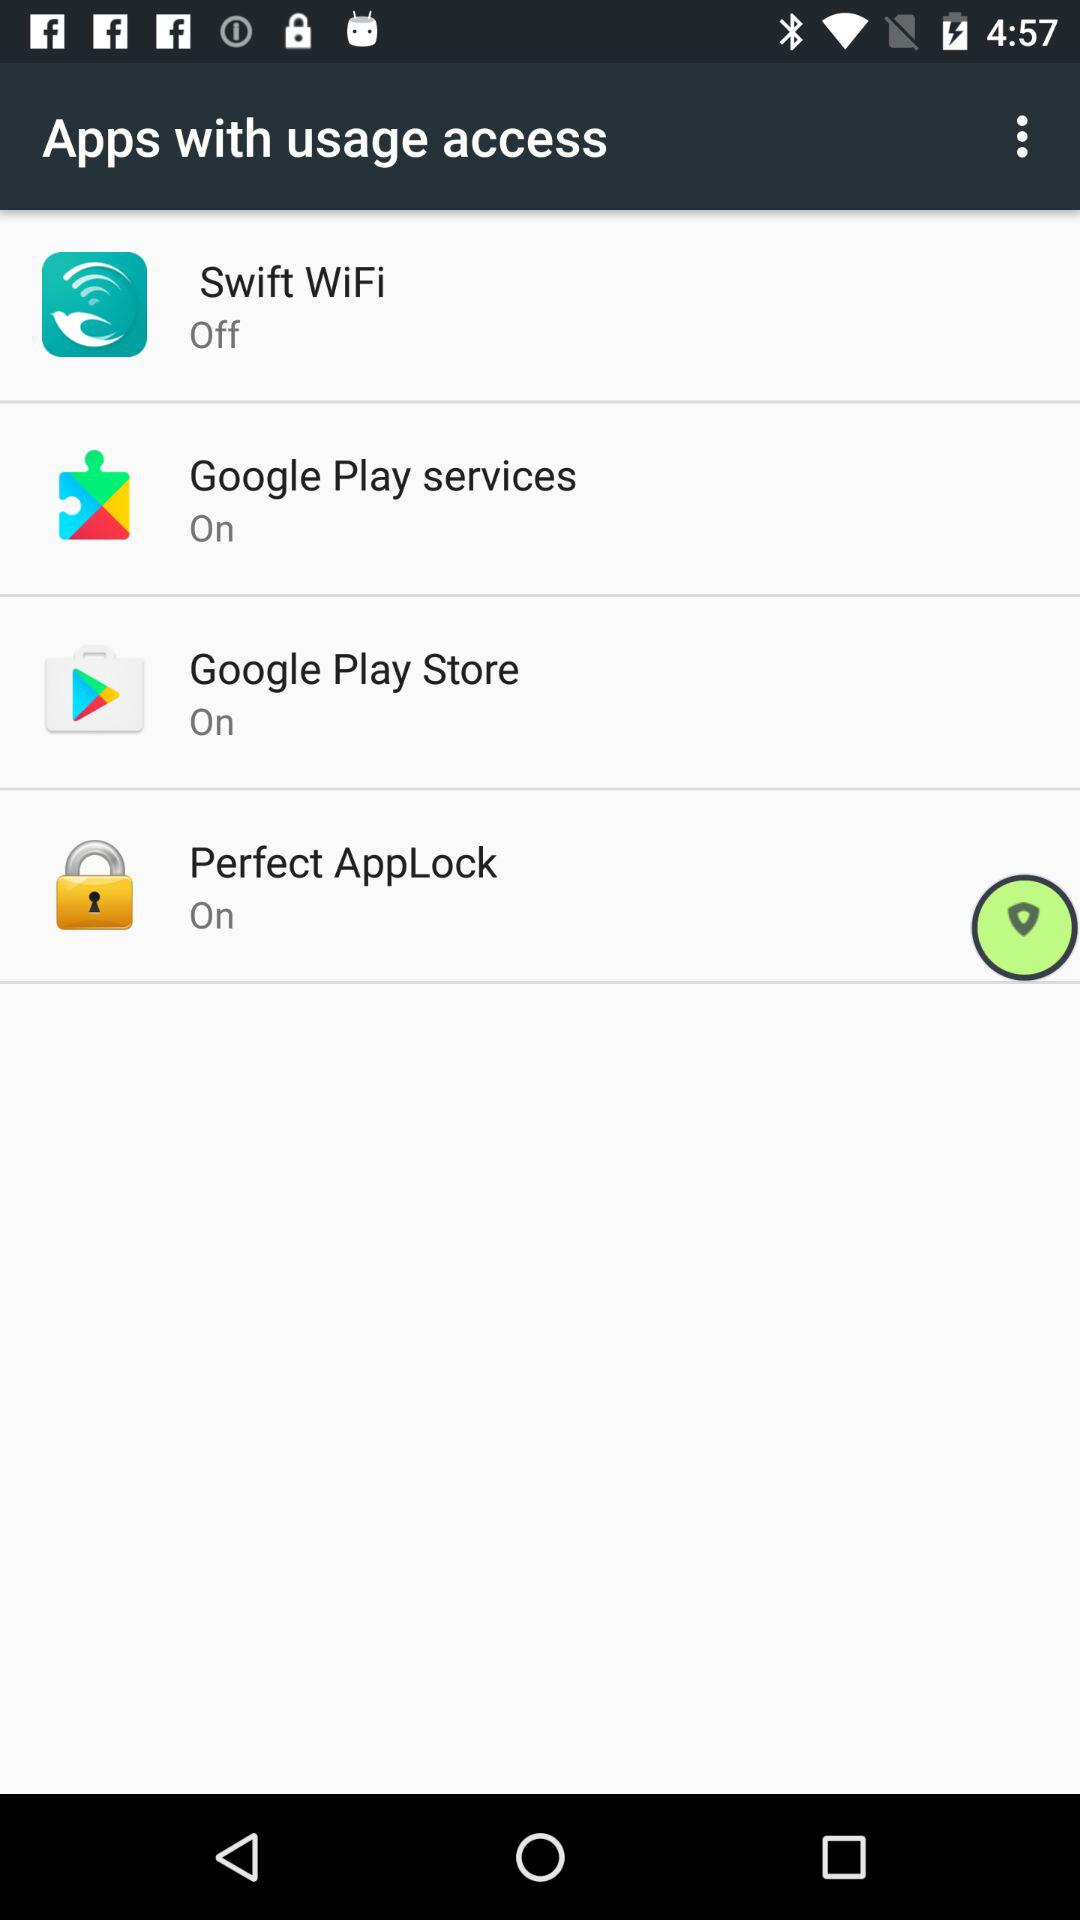How many apps are off?
Answer the question using a single word or phrase. 1 